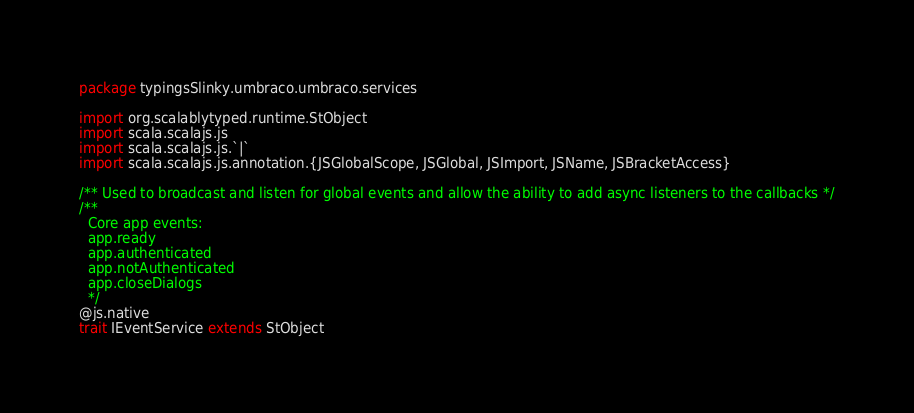<code> <loc_0><loc_0><loc_500><loc_500><_Scala_>package typingsSlinky.umbraco.umbraco.services

import org.scalablytyped.runtime.StObject
import scala.scalajs.js
import scala.scalajs.js.`|`
import scala.scalajs.js.annotation.{JSGlobalScope, JSGlobal, JSImport, JSName, JSBracketAccess}

/** Used to broadcast and listen for global events and allow the ability to add async listeners to the callbacks */
/**
  Core app events:
  app.ready
  app.authenticated
  app.notAuthenticated
  app.closeDialogs
  */
@js.native
trait IEventService extends StObject
</code> 